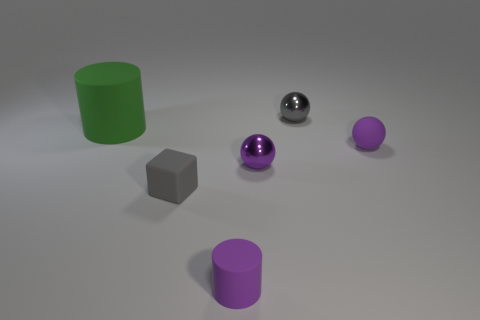Subtract all shiny balls. How many balls are left? 1 Add 1 green matte cylinders. How many objects exist? 7 Subtract all red blocks. How many purple balls are left? 2 Subtract 2 cylinders. How many cylinders are left? 0 Subtract all green cylinders. How many cylinders are left? 1 Subtract all cylinders. How many objects are left? 4 Subtract all red balls. Subtract all brown cylinders. How many balls are left? 3 Subtract all purple rubber objects. Subtract all gray things. How many objects are left? 2 Add 1 purple things. How many purple things are left? 4 Add 5 small brown spheres. How many small brown spheres exist? 5 